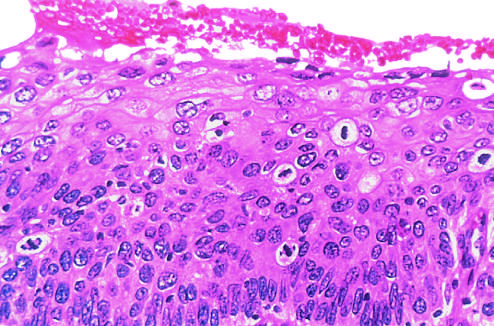s the wound around one another with regularly spaced binding of the congo red not seen in this section?
Answer the question using a single word or phrase. No 